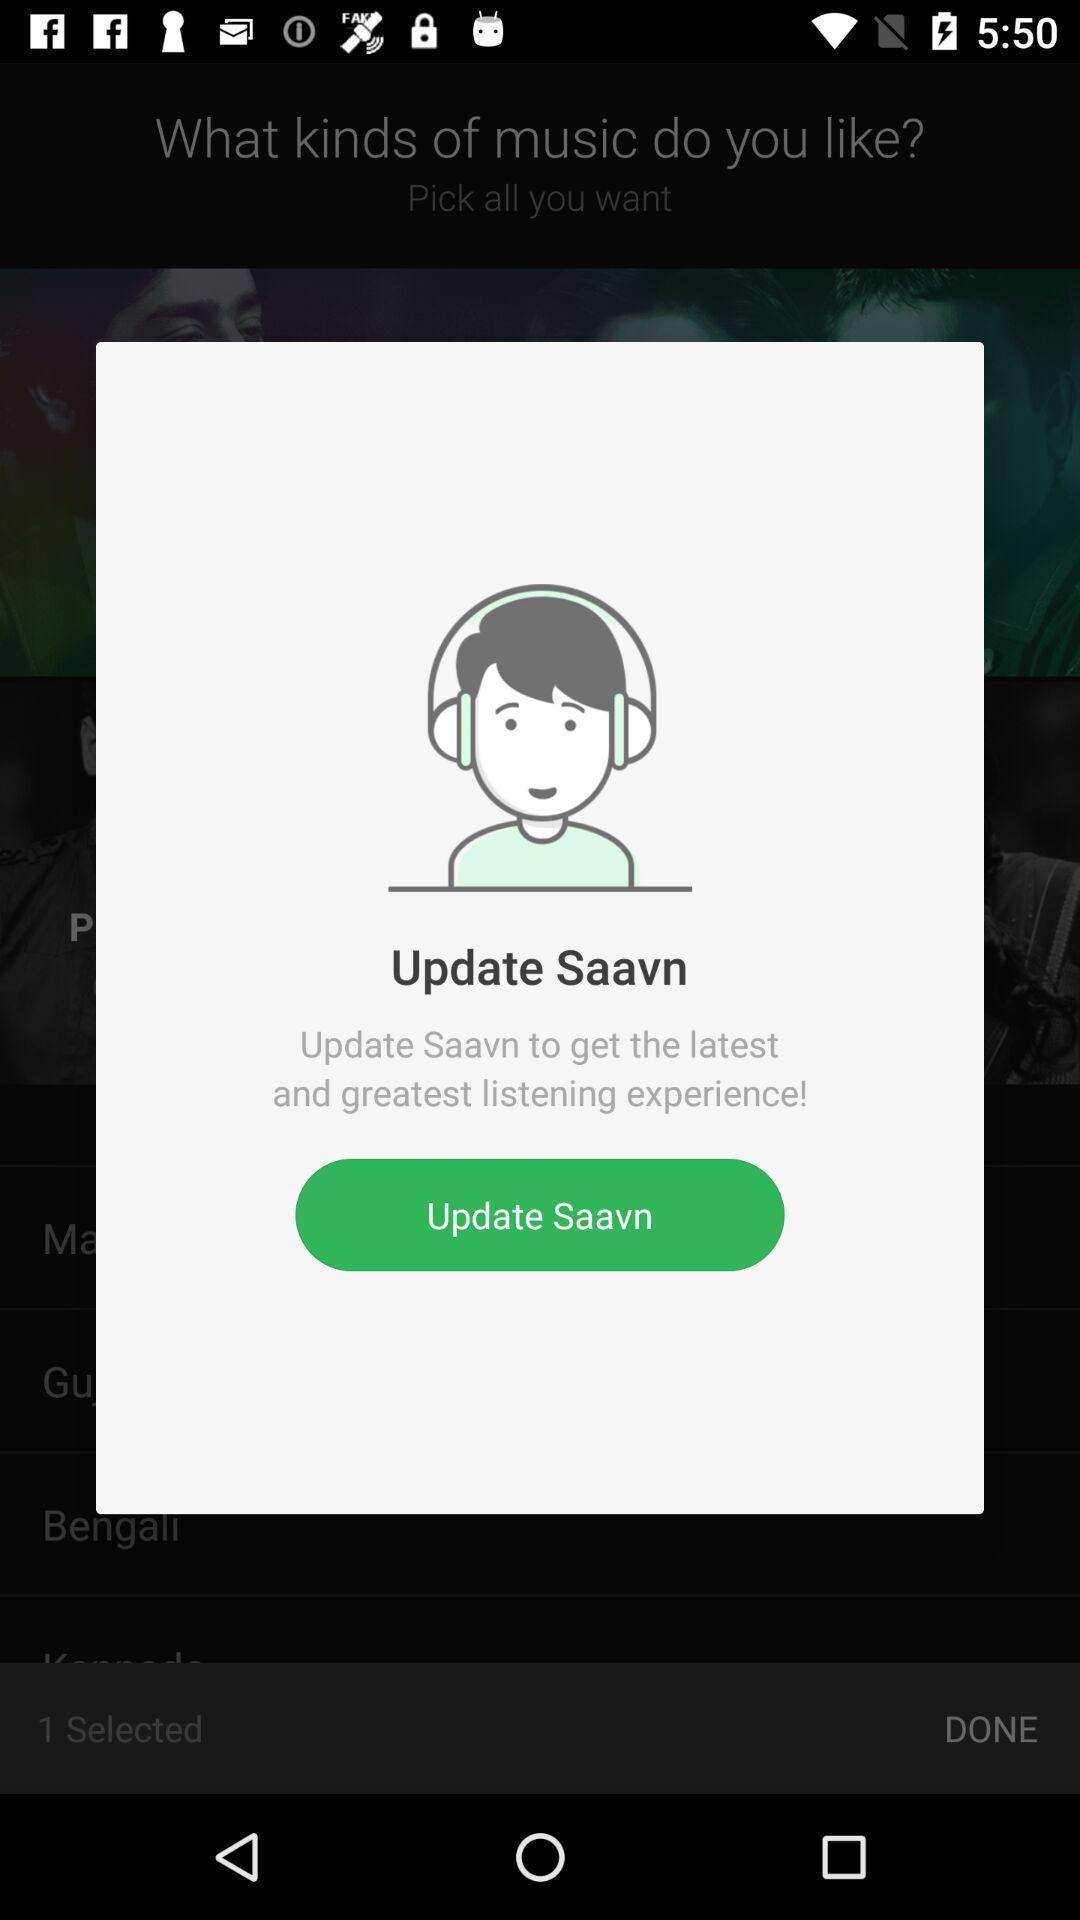Tell me what you see in this picture. Pop-up showing update message to update music app. 